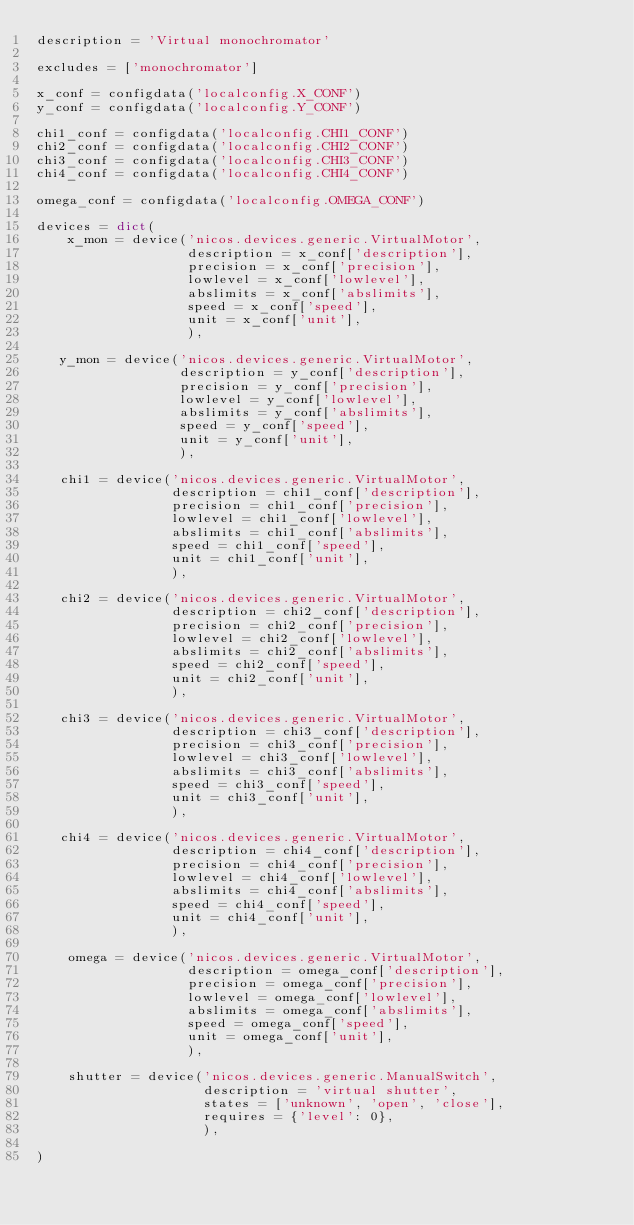Convert code to text. <code><loc_0><loc_0><loc_500><loc_500><_Python_>description = 'Virtual monochromator'

excludes = ['monochromator']

x_conf = configdata('localconfig.X_CONF')
y_conf = configdata('localconfig.Y_CONF')

chi1_conf = configdata('localconfig.CHI1_CONF')
chi2_conf = configdata('localconfig.CHI2_CONF')
chi3_conf = configdata('localconfig.CHI3_CONF')
chi4_conf = configdata('localconfig.CHI4_CONF')

omega_conf = configdata('localconfig.OMEGA_CONF')

devices = dict(
    x_mon = device('nicos.devices.generic.VirtualMotor',
                   description = x_conf['description'],
                   precision = x_conf['precision'],
                   lowlevel = x_conf['lowlevel'],
                   abslimits = x_conf['abslimits'],
                   speed = x_conf['speed'],
                   unit = x_conf['unit'],
                   ),

   y_mon = device('nicos.devices.generic.VirtualMotor',
                  description = y_conf['description'],
                  precision = y_conf['precision'],
                  lowlevel = y_conf['lowlevel'],
                  abslimits = y_conf['abslimits'],
                  speed = y_conf['speed'],
                  unit = y_conf['unit'],
                  ),

   chi1 = device('nicos.devices.generic.VirtualMotor',
                 description = chi1_conf['description'],
                 precision = chi1_conf['precision'],
                 lowlevel = chi1_conf['lowlevel'],
                 abslimits = chi1_conf['abslimits'],
                 speed = chi1_conf['speed'],
                 unit = chi1_conf['unit'],
                 ),

   chi2 = device('nicos.devices.generic.VirtualMotor',
                 description = chi2_conf['description'],
                 precision = chi2_conf['precision'],
                 lowlevel = chi2_conf['lowlevel'],
                 abslimits = chi2_conf['abslimits'],
                 speed = chi2_conf['speed'],
                 unit = chi2_conf['unit'],
                 ),

   chi3 = device('nicos.devices.generic.VirtualMotor',
                 description = chi3_conf['description'],
                 precision = chi3_conf['precision'],
                 lowlevel = chi3_conf['lowlevel'],
                 abslimits = chi3_conf['abslimits'],
                 speed = chi3_conf['speed'],
                 unit = chi3_conf['unit'],
                 ),

   chi4 = device('nicos.devices.generic.VirtualMotor',
                 description = chi4_conf['description'],
                 precision = chi4_conf['precision'],
                 lowlevel = chi4_conf['lowlevel'],
                 abslimits = chi4_conf['abslimits'],
                 speed = chi4_conf['speed'],
                 unit = chi4_conf['unit'],
                 ),

    omega = device('nicos.devices.generic.VirtualMotor',
                   description = omega_conf['description'],
                   precision = omega_conf['precision'],
                   lowlevel = omega_conf['lowlevel'],
                   abslimits = omega_conf['abslimits'],
                   speed = omega_conf['speed'],
                   unit = omega_conf['unit'],
                   ),

    shutter = device('nicos.devices.generic.ManualSwitch',
                     description = 'virtual shutter',
                     states = ['unknown', 'open', 'close'],
                     requires = {'level': 0},
                     ),

)

</code> 